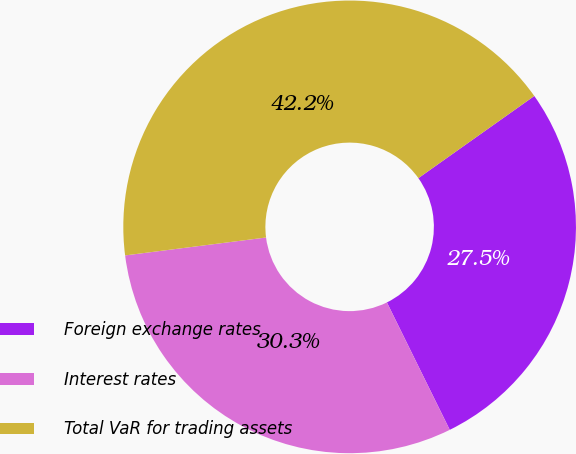<chart> <loc_0><loc_0><loc_500><loc_500><pie_chart><fcel>Foreign exchange rates<fcel>Interest rates<fcel>Total VaR for trading assets<nl><fcel>27.52%<fcel>30.28%<fcel>42.2%<nl></chart> 